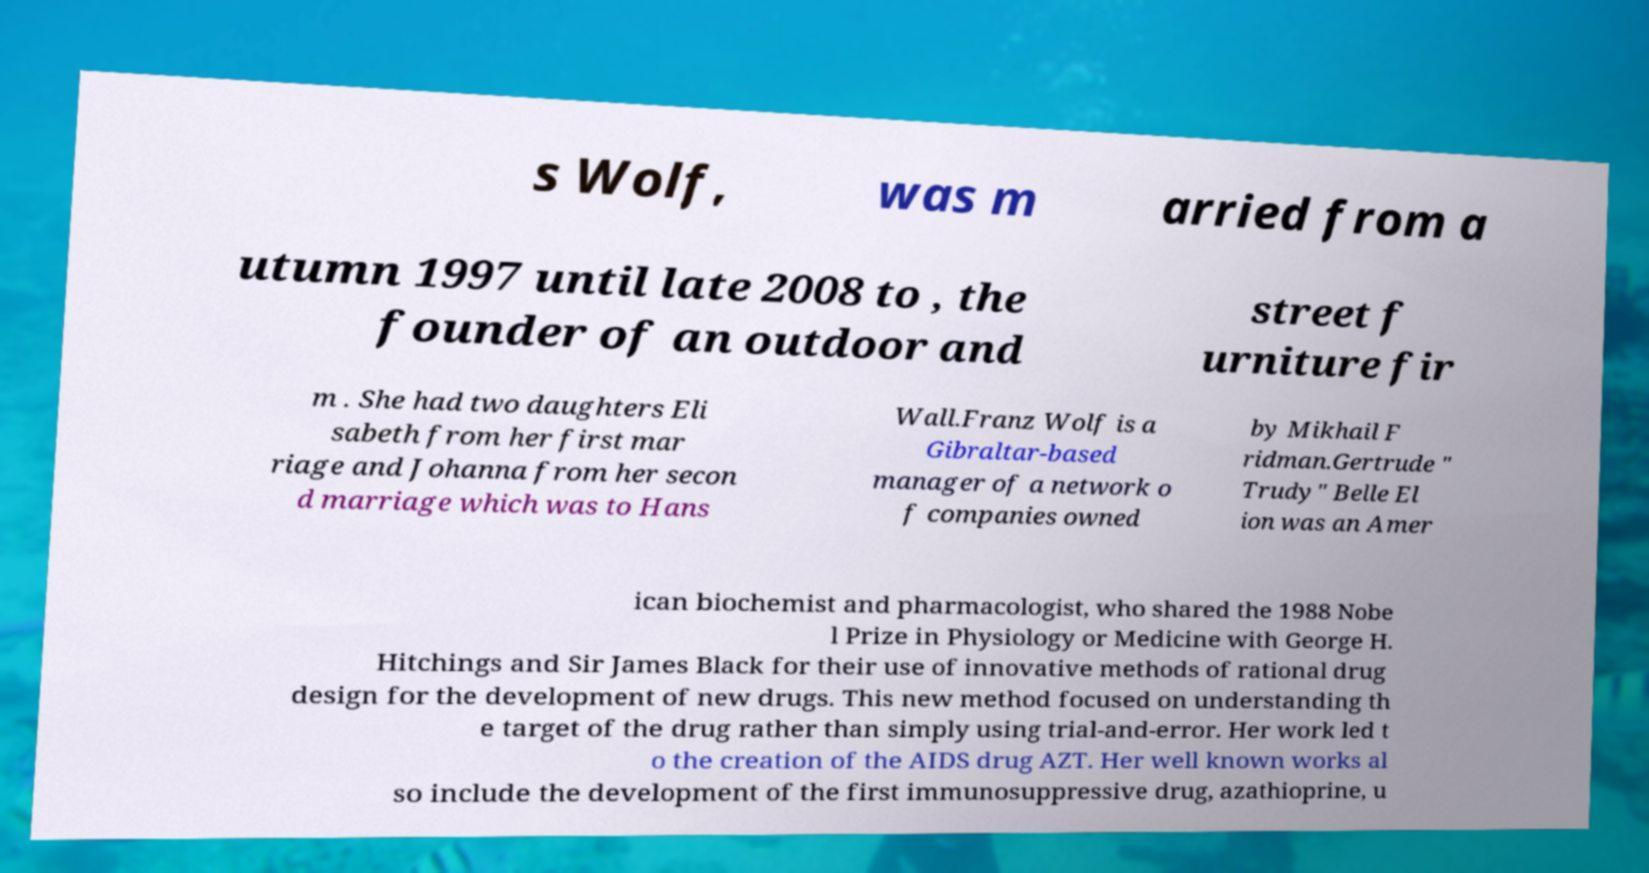Please identify and transcribe the text found in this image. s Wolf, was m arried from a utumn 1997 until late 2008 to , the founder of an outdoor and street f urniture fir m . She had two daughters Eli sabeth from her first mar riage and Johanna from her secon d marriage which was to Hans Wall.Franz Wolf is a Gibraltar-based manager of a network o f companies owned by Mikhail F ridman.Gertrude " Trudy" Belle El ion was an Amer ican biochemist and pharmacologist, who shared the 1988 Nobe l Prize in Physiology or Medicine with George H. Hitchings and Sir James Black for their use of innovative methods of rational drug design for the development of new drugs. This new method focused on understanding th e target of the drug rather than simply using trial-and-error. Her work led t o the creation of the AIDS drug AZT. Her well known works al so include the development of the first immunosuppressive drug, azathioprine, u 